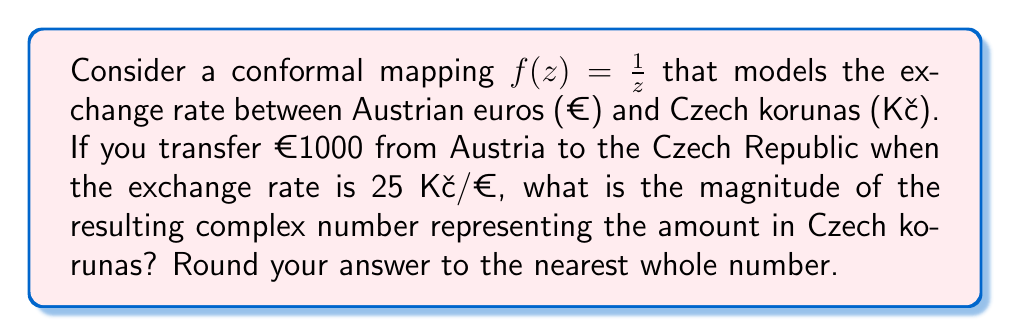Can you solve this math problem? Let's approach this step-by-step:

1) First, we need to represent the initial amount in the complex plane. Since we're starting with euros, we'll use the real axis. So, €1000 is represented as the complex number $z = 1000 + 0i$.

2) The exchange rate of 25 Kč/€ means that for each euro, you get 25 korunas. We can represent this as a scaling factor in our conformal mapping.

3) The conformal mapping $f(z) = \frac{1}{z}$ inverts the complex plane. To incorporate the exchange rate, we need to scale this mapping by 25000 (1000 * 25). So our actual mapping becomes:

   $$f(z) = \frac{25000}{z}$$

4) Now, let's apply this mapping to our initial point:

   $$f(1000 + 0i) = \frac{25000}{1000 + 0i} = 25 + 0i$$

5) The resulting complex number is 25 + 0i, which represents 25000 Czech korunas.

6) To find the magnitude of this complex number, we use the formula $|a + bi| = \sqrt{a^2 + b^2}$:

   $$|25 + 0i| = \sqrt{25^2 + 0^2} = \sqrt{625} = 25$$

Therefore, the magnitude of the resulting complex number is 25, which represents 25000 Czech korunas.
Answer: 25 